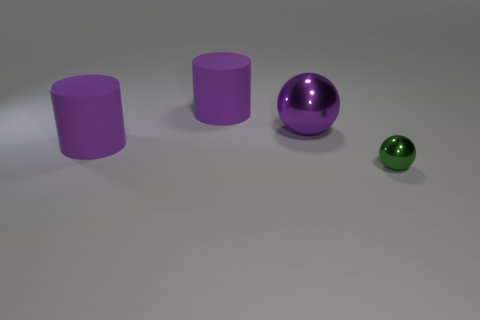There is a metal thing behind the small green metallic sphere; is it the same shape as the small green metallic thing?
Keep it short and to the point. Yes. How many things are either big yellow cylinders or tiny shiny spheres?
Make the answer very short. 1. Does the sphere in front of the large purple metallic ball have the same material as the big purple ball?
Keep it short and to the point. Yes. The purple shiny thing has what size?
Offer a very short reply. Large. What number of cylinders are either tiny objects or big purple objects?
Offer a very short reply. 2. Are there an equal number of spheres to the right of the tiny metal ball and large things that are behind the purple shiny object?
Your response must be concise. No. There is a purple metallic object that is the same shape as the green metallic object; what is its size?
Your response must be concise. Large. What is the size of the object that is in front of the big shiny thing and behind the small green ball?
Your answer should be compact. Large. There is a small metallic sphere; are there any purple metallic spheres in front of it?
Your response must be concise. No. What number of objects are spheres on the left side of the small ball or purple matte cylinders?
Your answer should be compact. 3. 